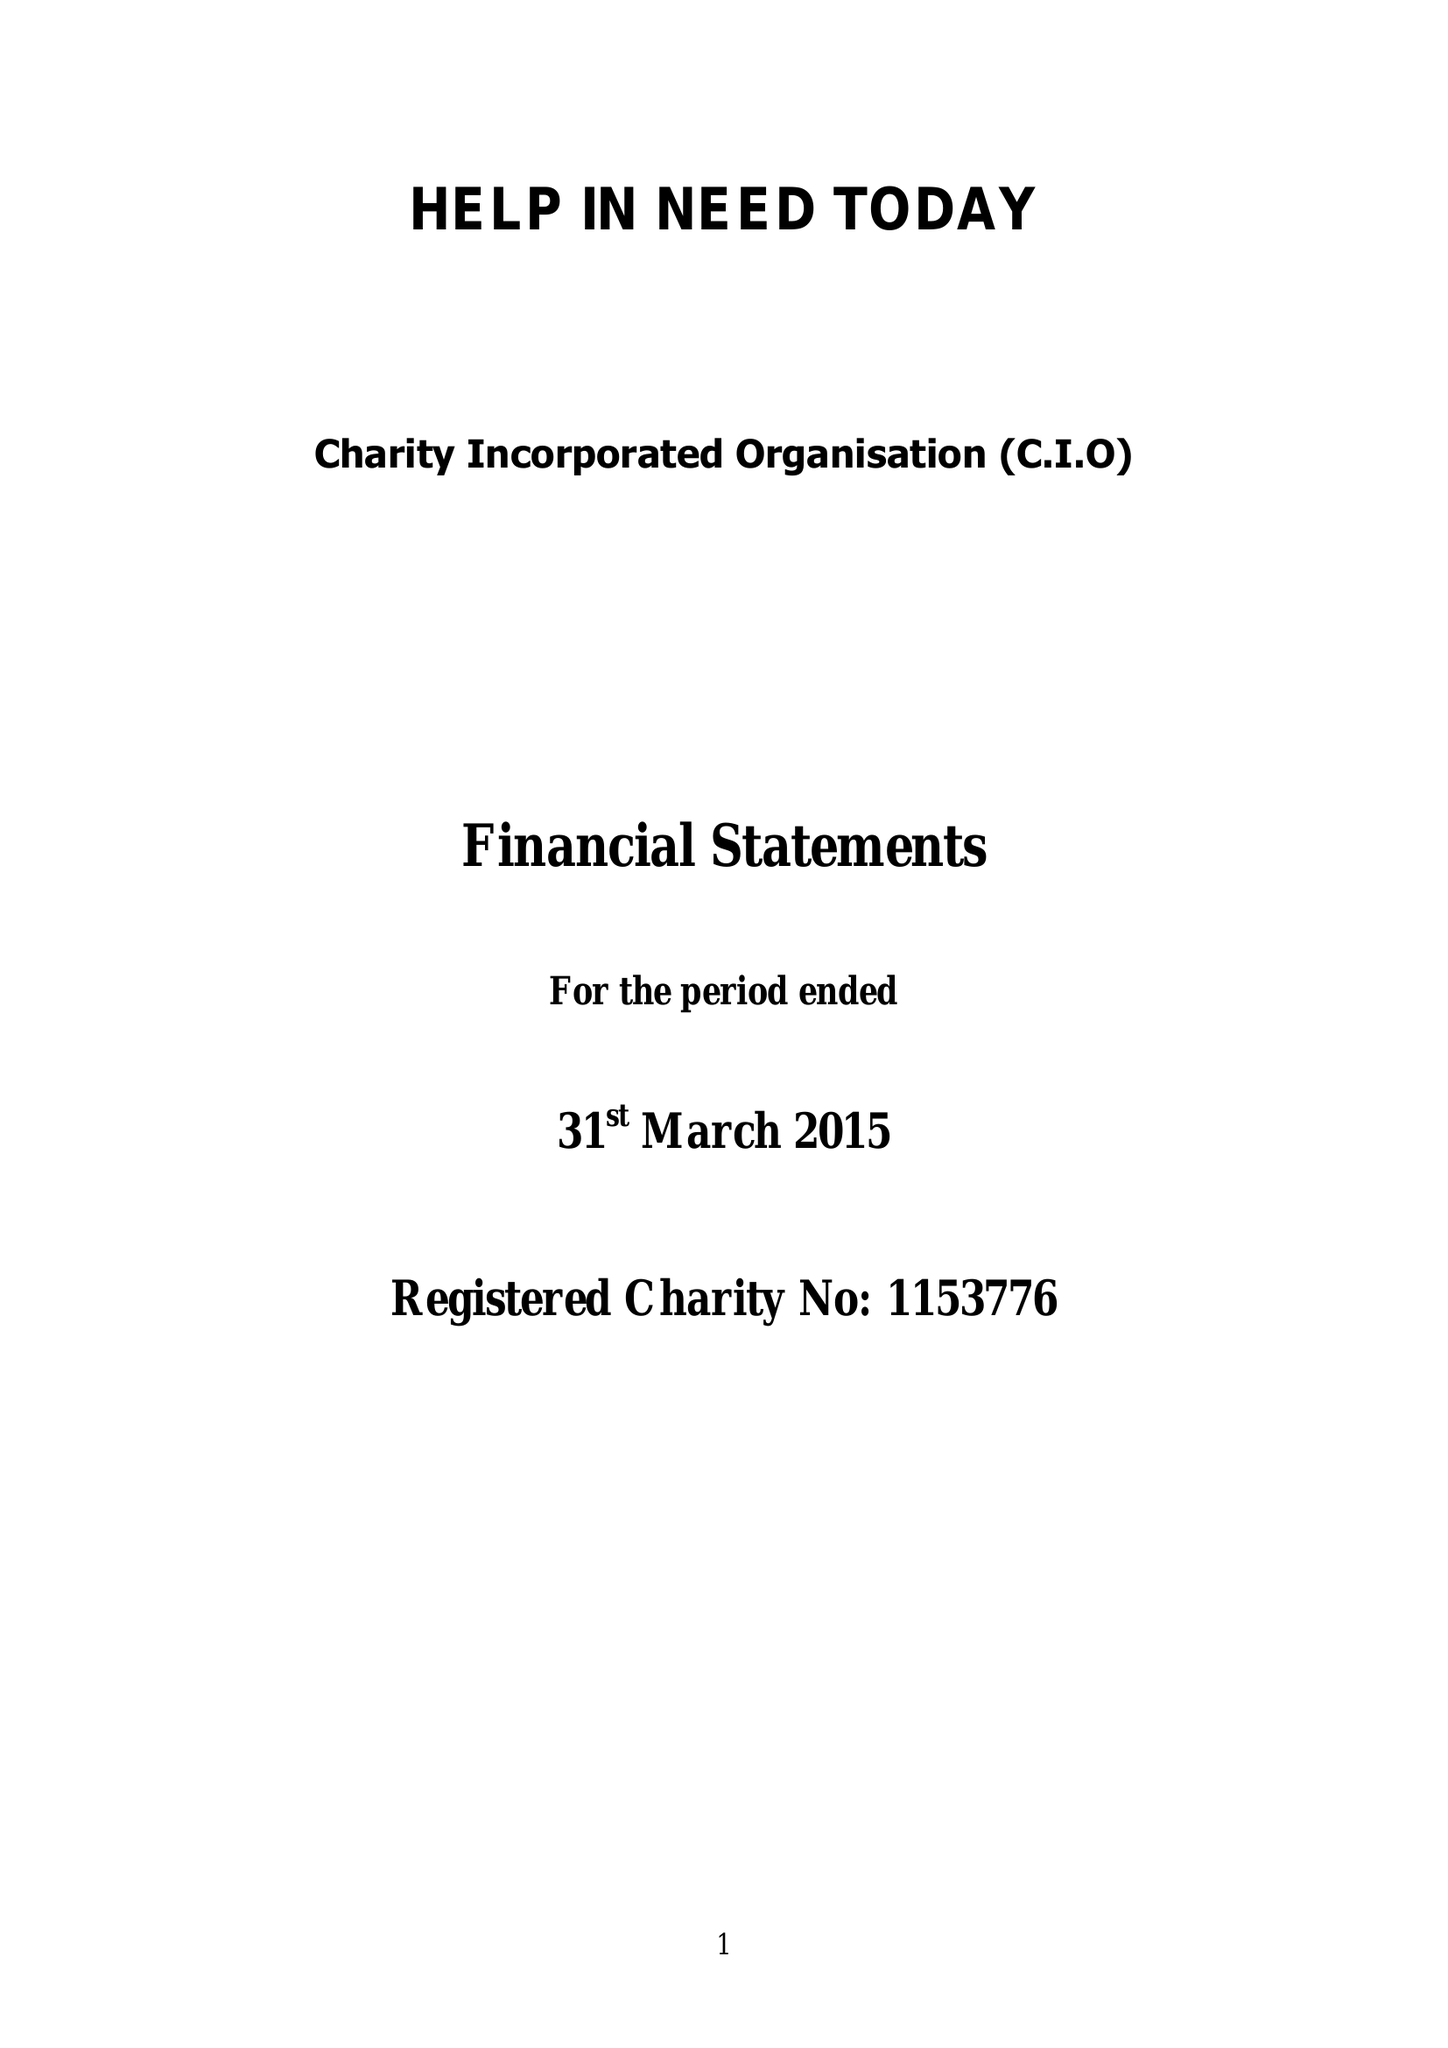What is the value for the charity_name?
Answer the question using a single word or phrase. Help In Need Today 